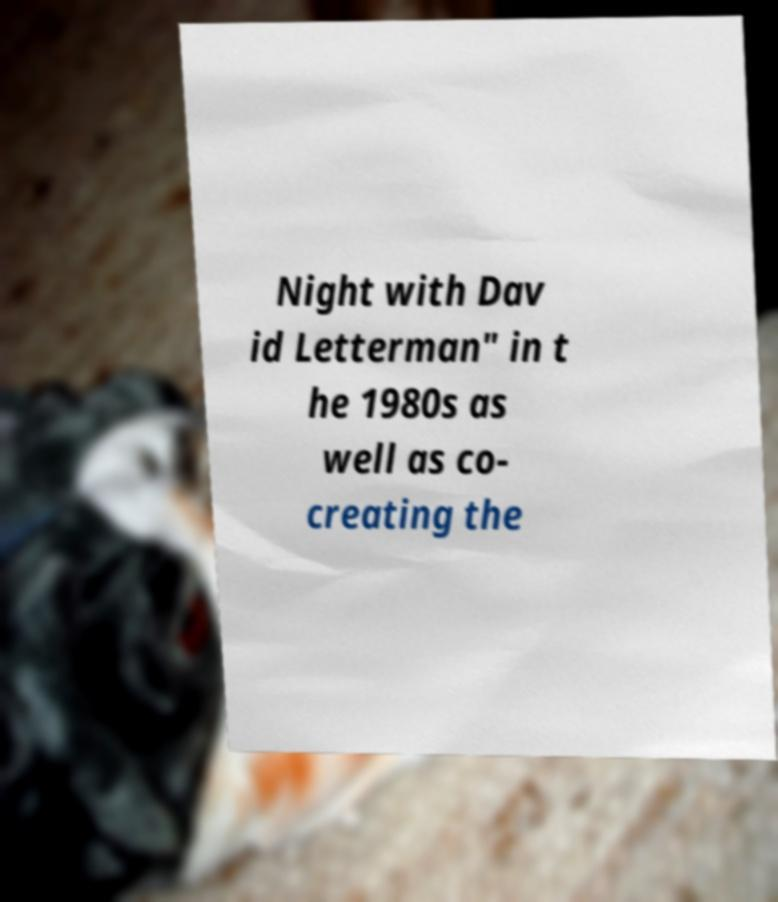I need the written content from this picture converted into text. Can you do that? Night with Dav id Letterman" in t he 1980s as well as co- creating the 